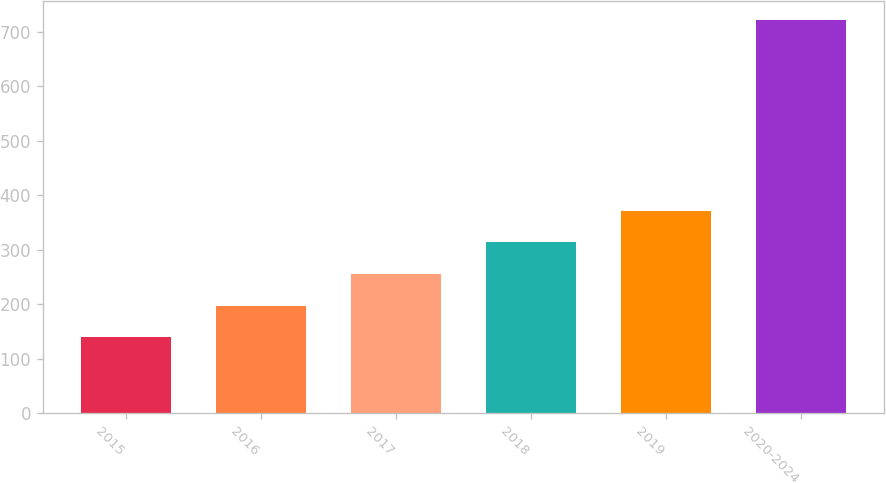Convert chart. <chart><loc_0><loc_0><loc_500><loc_500><bar_chart><fcel>2015<fcel>2016<fcel>2017<fcel>2018<fcel>2019<fcel>2020-2024<nl><fcel>139<fcel>197.2<fcel>255.4<fcel>313.6<fcel>371.8<fcel>721<nl></chart> 